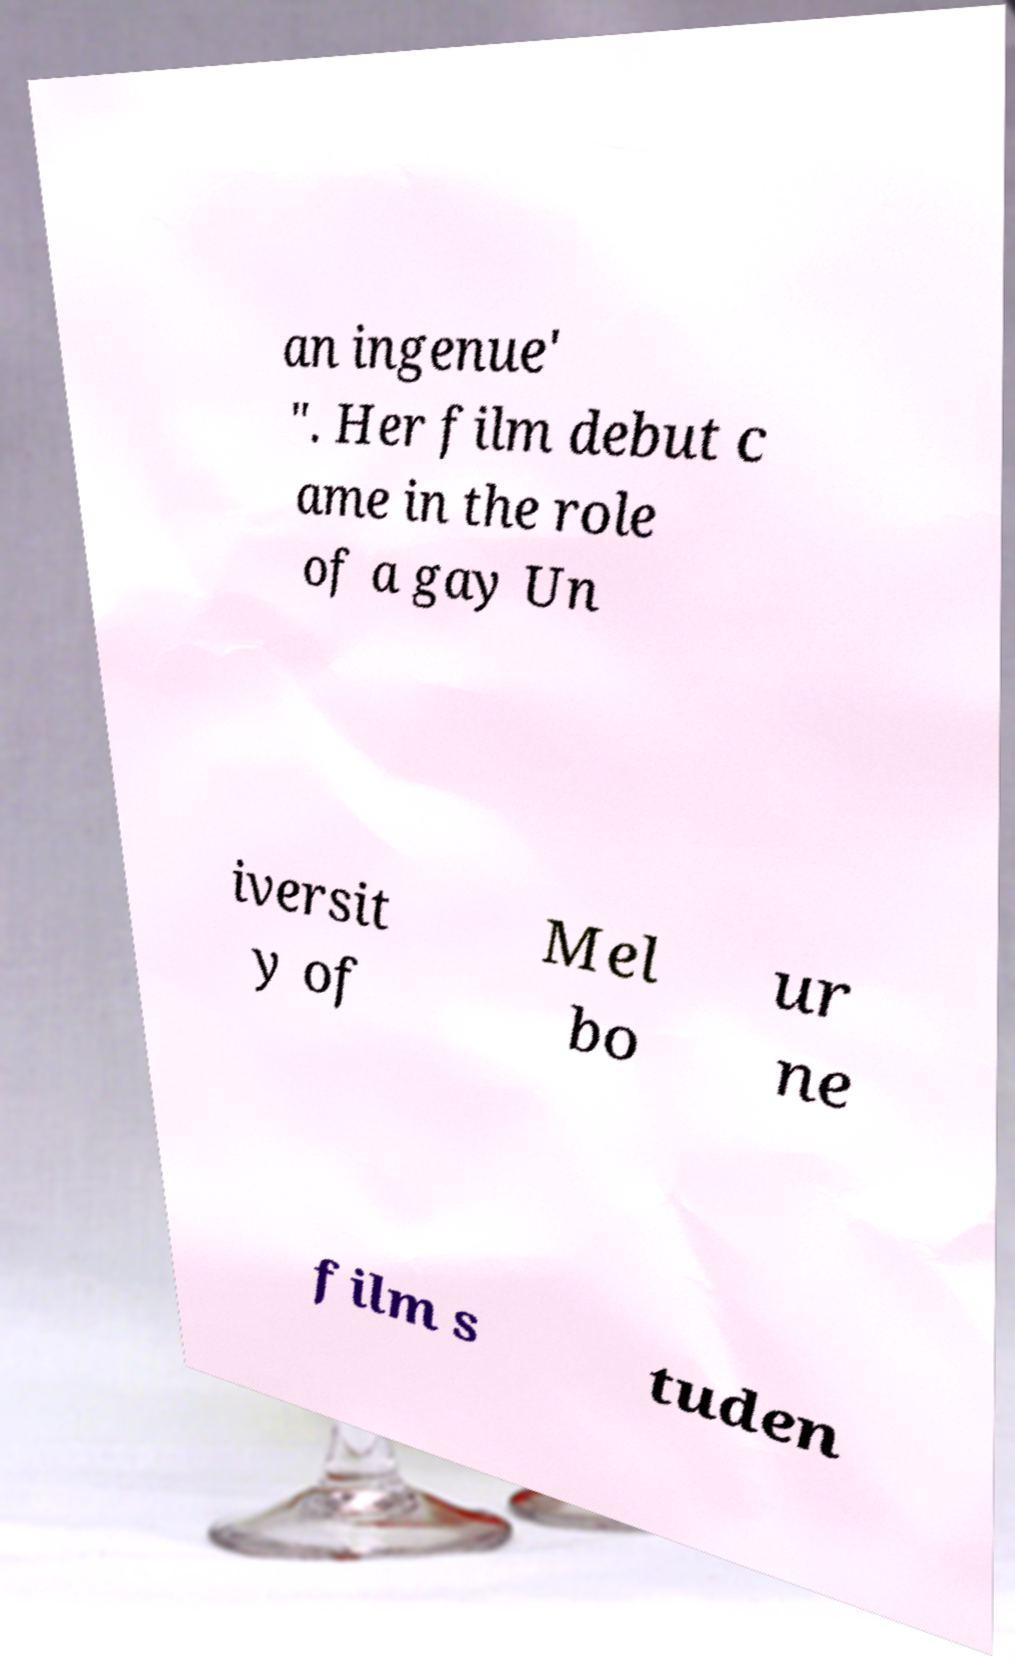What messages or text are displayed in this image? I need them in a readable, typed format. an ingenue' ". Her film debut c ame in the role of a gay Un iversit y of Mel bo ur ne film s tuden 